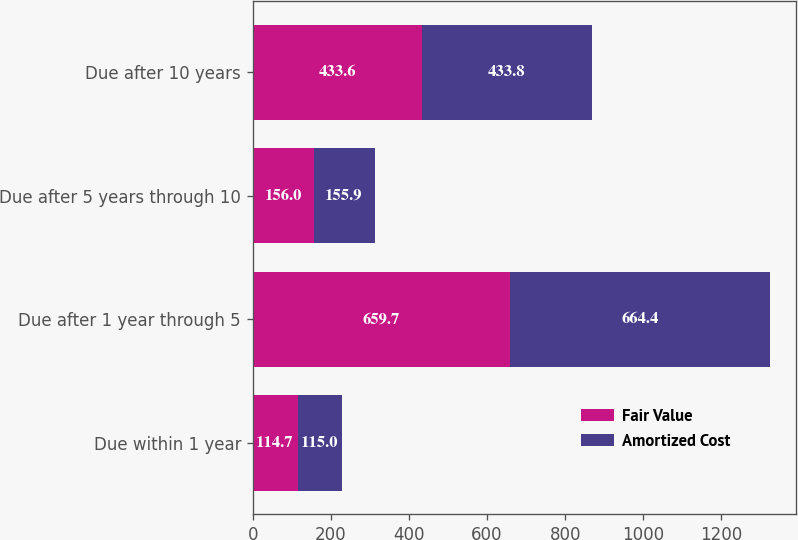Convert chart to OTSL. <chart><loc_0><loc_0><loc_500><loc_500><stacked_bar_chart><ecel><fcel>Due within 1 year<fcel>Due after 1 year through 5<fcel>Due after 5 years through 10<fcel>Due after 10 years<nl><fcel>Fair Value<fcel>114.7<fcel>659.7<fcel>156<fcel>433.6<nl><fcel>Amortized Cost<fcel>115<fcel>664.4<fcel>155.9<fcel>433.8<nl></chart> 